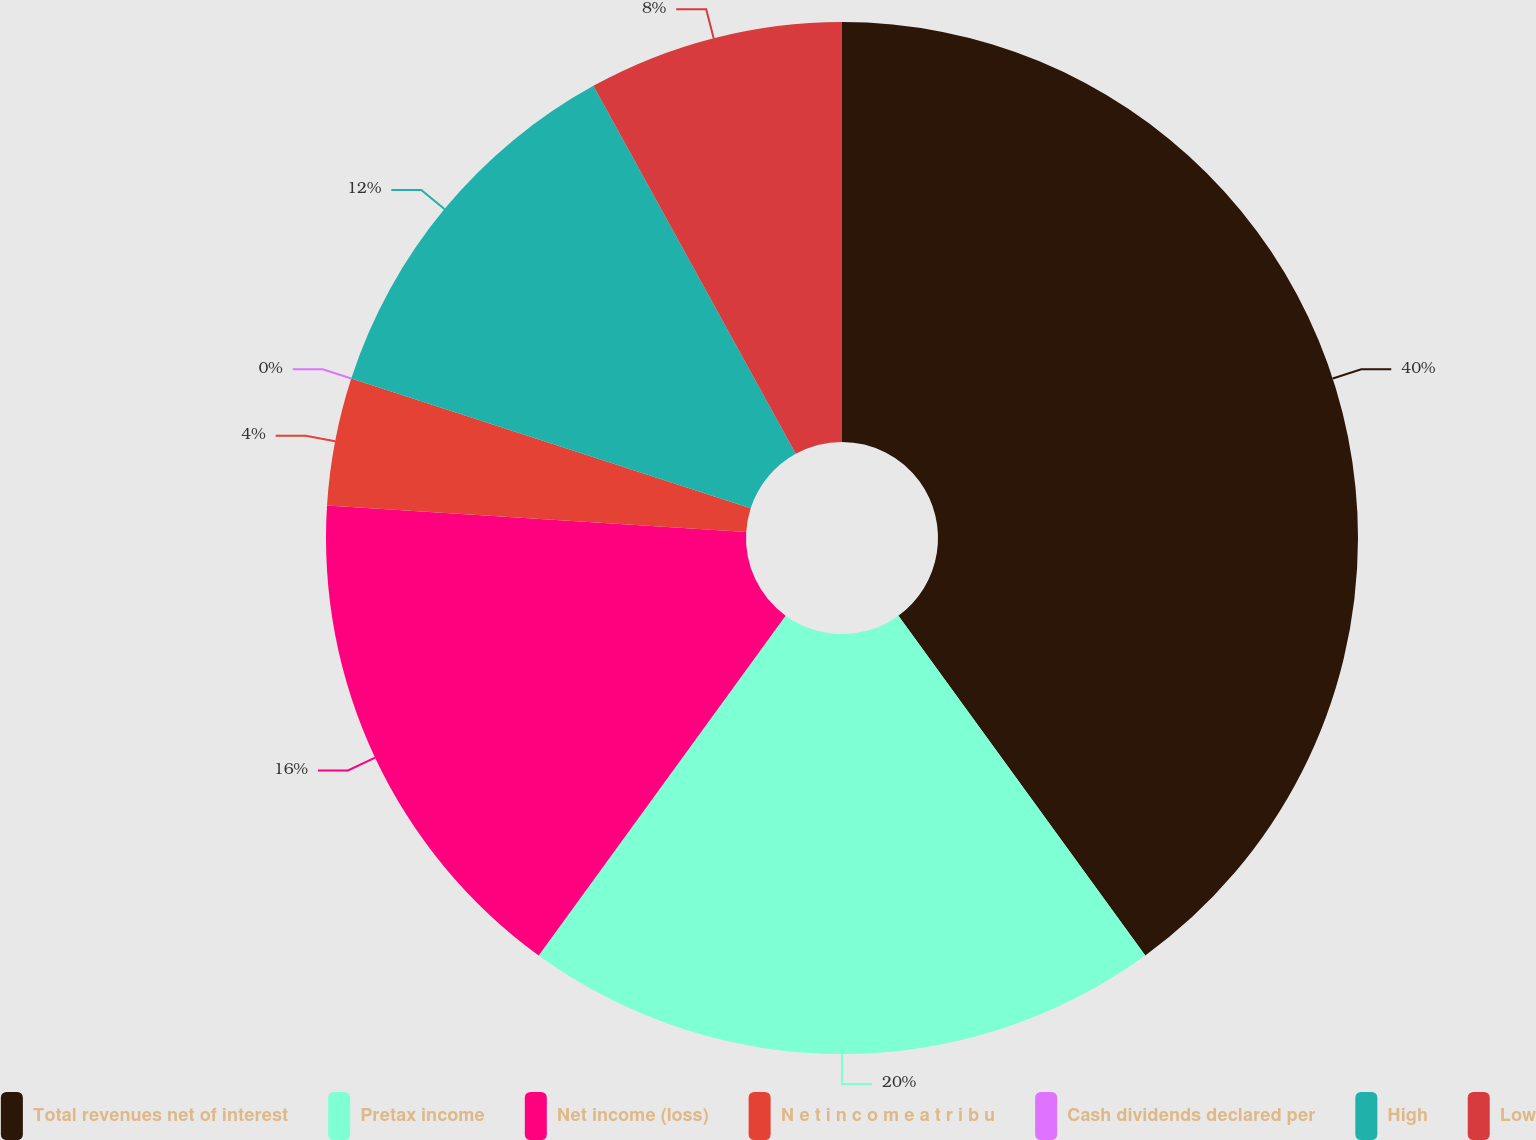Convert chart to OTSL. <chart><loc_0><loc_0><loc_500><loc_500><pie_chart><fcel>Total revenues net of interest<fcel>Pretax income<fcel>Net income (loss)<fcel>N e t i n c o m e a t r i b u<fcel>Cash dividends declared per<fcel>High<fcel>Low<nl><fcel>40.0%<fcel>20.0%<fcel>16.0%<fcel>4.0%<fcel>0.0%<fcel>12.0%<fcel>8.0%<nl></chart> 